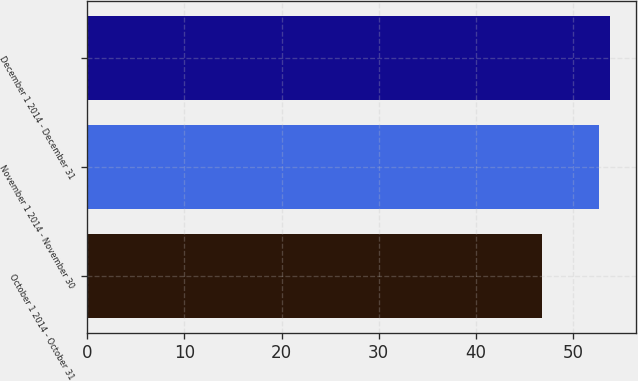Convert chart. <chart><loc_0><loc_0><loc_500><loc_500><bar_chart><fcel>October 1 2014 - October 31<fcel>November 1 2014 - November 30<fcel>December 1 2014 - December 31<nl><fcel>46.8<fcel>52.68<fcel>53.84<nl></chart> 